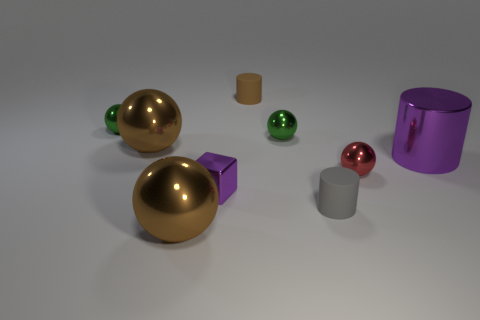Subtract all large brown shiny spheres. How many spheres are left? 3 Subtract 1 spheres. How many spheres are left? 4 Subtract all gray spheres. Subtract all purple blocks. How many spheres are left? 5 Subtract all brown spheres. How many gray cylinders are left? 1 Subtract all large spheres. Subtract all big brown metallic spheres. How many objects are left? 5 Add 5 small gray objects. How many small gray objects are left? 6 Add 6 rubber objects. How many rubber objects exist? 8 Subtract all red spheres. How many spheres are left? 4 Subtract 0 red cubes. How many objects are left? 9 Subtract all cylinders. How many objects are left? 6 